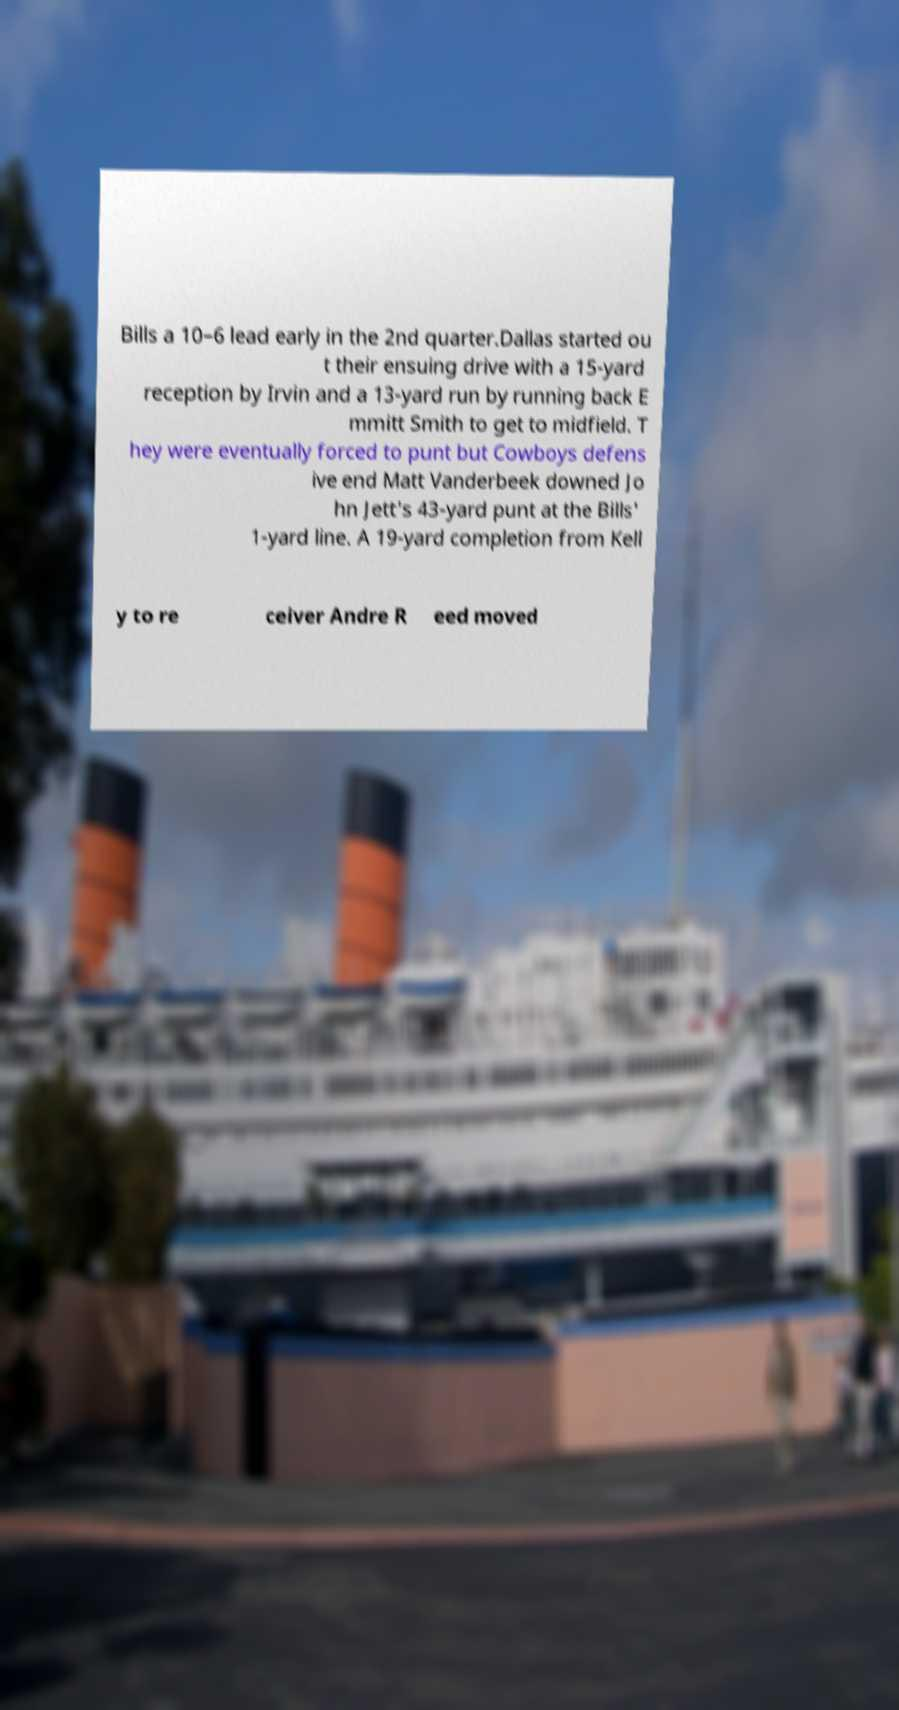Please identify and transcribe the text found in this image. Bills a 10–6 lead early in the 2nd quarter.Dallas started ou t their ensuing drive with a 15-yard reception by Irvin and a 13-yard run by running back E mmitt Smith to get to midfield. T hey were eventually forced to punt but Cowboys defens ive end Matt Vanderbeek downed Jo hn Jett's 43-yard punt at the Bills' 1-yard line. A 19-yard completion from Kell y to re ceiver Andre R eed moved 